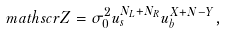Convert formula to latex. <formula><loc_0><loc_0><loc_500><loc_500>\ m a t h s c r { Z } = \sigma _ { 0 } ^ { 2 } u _ { s } ^ { N _ { L } + N _ { R } } u _ { b } ^ { X + N - Y } ,</formula> 